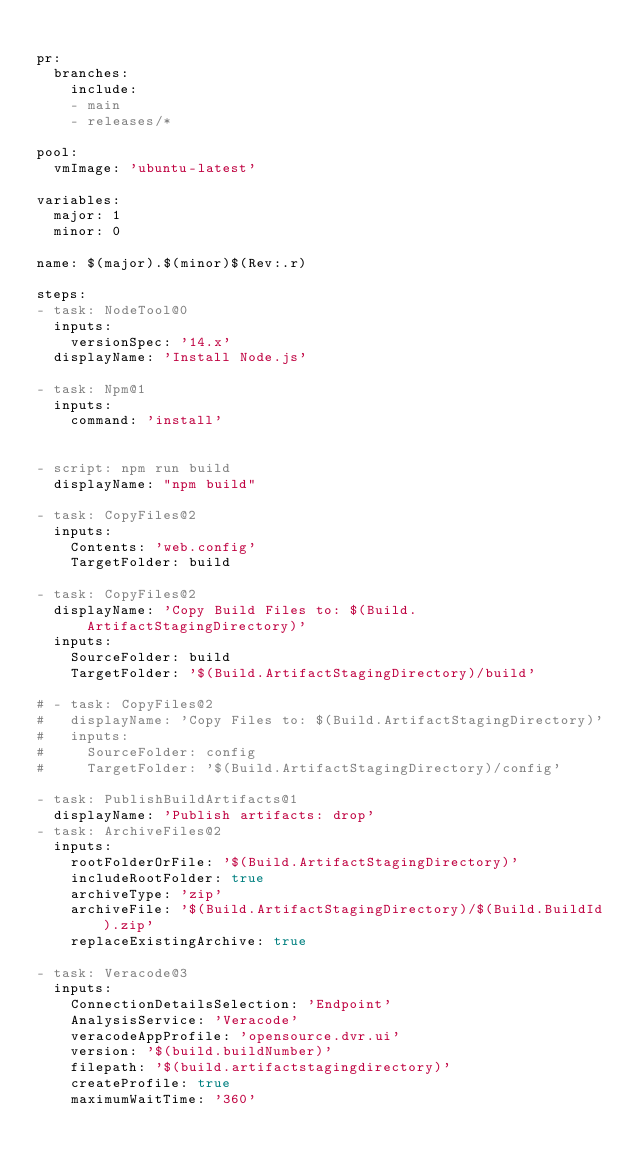Convert code to text. <code><loc_0><loc_0><loc_500><loc_500><_YAML_>
pr:
  branches:
    include:
    - main
    - releases/*
  
pool:
  vmImage: 'ubuntu-latest'

variables:
  major: 1
  minor: 0
   
name: $(major).$(minor)$(Rev:.r)
  
steps:  
- task: NodeTool@0
  inputs:
    versionSpec: '14.x'
  displayName: 'Install Node.js'

- task: Npm@1
  inputs:
    command: 'install'

    
- script: npm run build
  displayName: "npm build"

- task: CopyFiles@2
  inputs:
    Contents: 'web.config'
    TargetFolder: build

- task: CopyFiles@2
  displayName: 'Copy Build Files to: $(Build.ArtifactStagingDirectory)'
  inputs:
    SourceFolder: build
    TargetFolder: '$(Build.ArtifactStagingDirectory)/build'

# - task: CopyFiles@2
#   displayName: 'Copy Files to: $(Build.ArtifactStagingDirectory)'
#   inputs:
#     SourceFolder: config
#     TargetFolder: '$(Build.ArtifactStagingDirectory)/config'

- task: PublishBuildArtifacts@1
  displayName: 'Publish artifacts: drop'
- task: ArchiveFiles@2
  inputs:
    rootFolderOrFile: '$(Build.ArtifactStagingDirectory)'
    includeRootFolder: true
    archiveType: 'zip'
    archiveFile: '$(Build.ArtifactStagingDirectory)/$(Build.BuildId).zip'
    replaceExistingArchive: true

- task: Veracode@3
  inputs:
    ConnectionDetailsSelection: 'Endpoint'
    AnalysisService: 'Veracode'
    veracodeAppProfile: 'opensource.dvr.ui'
    version: '$(build.buildNumber)'
    filepath: '$(build.artifactstagingdirectory)'
    createProfile: true
    maximumWaitTime: '360'</code> 